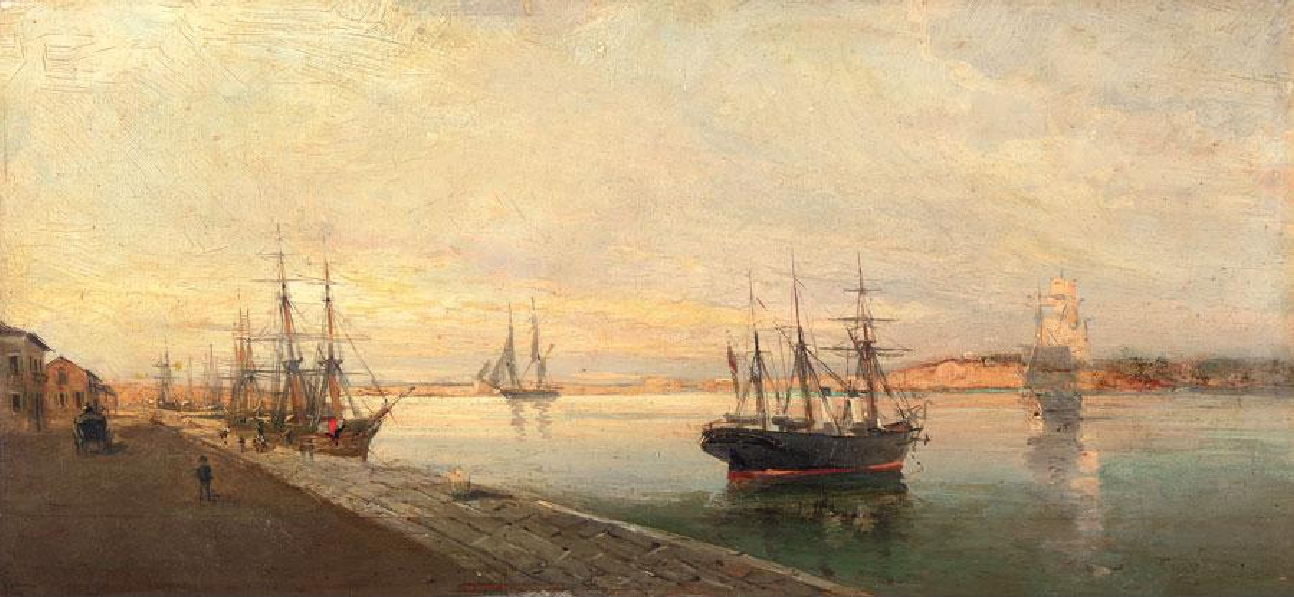What kind of stories might the dockworkers share in this scene? The dockworkers in this scene might share a variety of stories, from tales of daring sea voyages and encounters with storms to the mundane yet cherished moments of daily life. One worker might recount an adventurous journey battling fierce waves and navigating treacherous waters, while another could speak of incredible sights from far-off lands. Some might share humorous anecdotes of peculiar passengers or strange sea creatures spotted during trips. In quieter moments, they might exchange news and gossip about the harbor, discussing market prices, local events, and the comings and goings of familiar ships. Through these stories, a rich tapestry of maritime life, filled with excitement, hardship, and camaraderie, would unfold. 